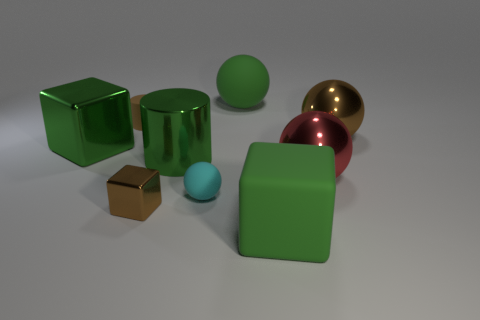Are there any tiny cyan matte objects right of the tiny matte sphere that is in front of the green metallic thing that is on the left side of the shiny cylinder?
Offer a very short reply. No. How many other things are made of the same material as the small brown cylinder?
Provide a succinct answer. 3. What number of large brown metal things are there?
Give a very brief answer. 1. How many objects are big purple cubes or rubber things that are in front of the tiny brown rubber thing?
Offer a very short reply. 2. Is there any other thing that has the same shape as the tiny brown matte thing?
Ensure brevity in your answer.  Yes. There is a shiny thing that is left of the brown cylinder; is its size the same as the green ball?
Your answer should be very brief. Yes. What number of shiny things are either big red things or brown objects?
Provide a succinct answer. 3. What size is the green rubber thing that is in front of the large green matte ball?
Provide a succinct answer. Large. Does the cyan rubber thing have the same shape as the brown matte object?
Ensure brevity in your answer.  No. What number of small things are either purple balls or green metal cubes?
Provide a short and direct response. 0. 